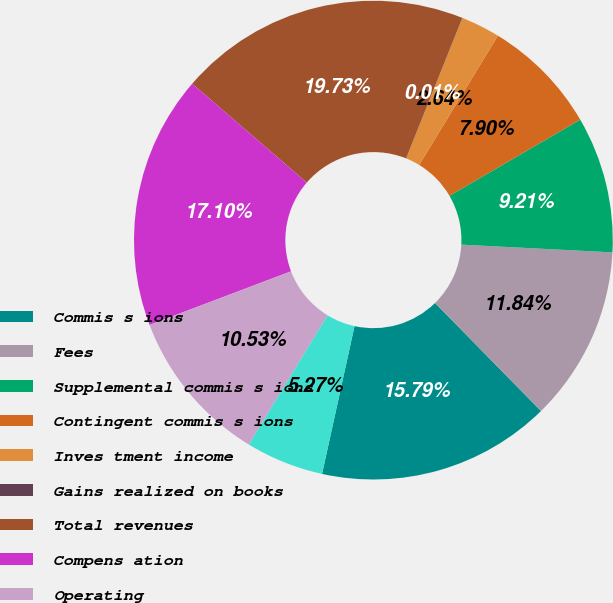Convert chart to OTSL. <chart><loc_0><loc_0><loc_500><loc_500><pie_chart><fcel>Commis s ions<fcel>Fees<fcel>Supplemental commis s ions<fcel>Contingent commis s ions<fcel>Inves tment income<fcel>Gains realized on books<fcel>Total revenues<fcel>Compens ation<fcel>Operating<fcel>Depreciation<nl><fcel>15.79%<fcel>11.84%<fcel>9.21%<fcel>7.9%<fcel>2.64%<fcel>0.01%<fcel>19.73%<fcel>17.1%<fcel>10.53%<fcel>5.27%<nl></chart> 